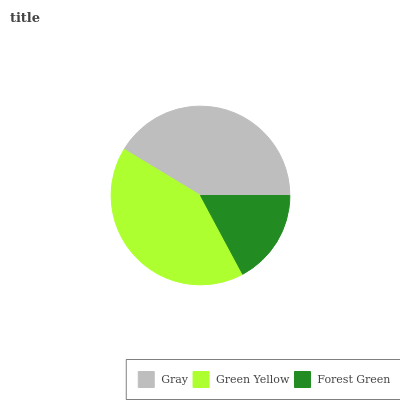Is Forest Green the minimum?
Answer yes or no. Yes. Is Green Yellow the maximum?
Answer yes or no. Yes. Is Green Yellow the minimum?
Answer yes or no. No. Is Forest Green the maximum?
Answer yes or no. No. Is Green Yellow greater than Forest Green?
Answer yes or no. Yes. Is Forest Green less than Green Yellow?
Answer yes or no. Yes. Is Forest Green greater than Green Yellow?
Answer yes or no. No. Is Green Yellow less than Forest Green?
Answer yes or no. No. Is Gray the high median?
Answer yes or no. Yes. Is Gray the low median?
Answer yes or no. Yes. Is Green Yellow the high median?
Answer yes or no. No. Is Green Yellow the low median?
Answer yes or no. No. 